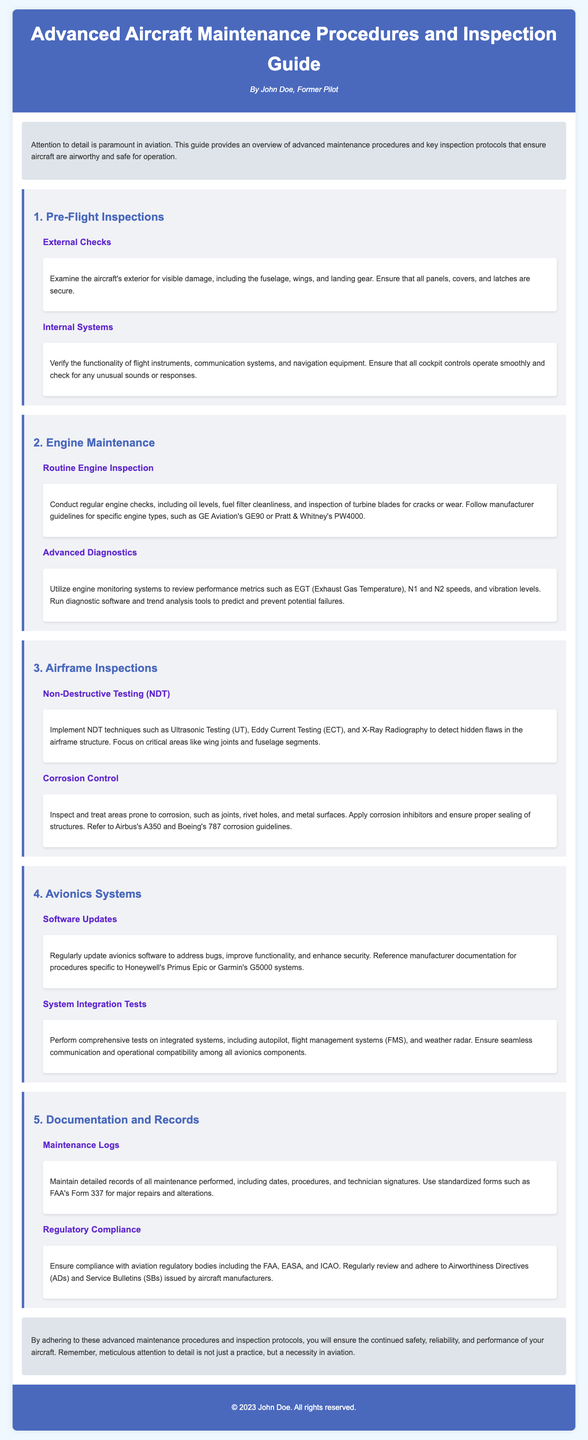What are the key focuses of pre-flight inspections? The pre-flight inspections are focused on external checks and internal systems to ensure aircraft safety.
Answer: External checks, internal systems Which systems require routine engine inspections? Routine engine inspections include checks on oil levels, fuel filter cleanliness, and inspection of turbine blades.
Answer: Oil levels, fuel filter cleanliness, turbine blades What does NDT stand for in airframe inspections? NDT stands for Non-Destructive Testing, which is used to detect hidden flaws in aircraft structures.
Answer: Non-Destructive Testing What type of maintenance logs should be maintained? Maintenance logs should include detailed records of all maintenance performed, such as dates, procedures, and technician signatures.
Answer: Detailed records How often should avionics software be updated? Avionics software should be updated regularly to address bugs, improve functionality, and enhance security.
Answer: Regularly What is the significance of corrosion inhibitors in maintenance? Corrosion inhibitors play a critical role in treating areas prone to corrosion on the aircraft.
Answer: Treating areas prone to corrosion What should be checked in the engine performance metrics? Engine performance metrics include EGT, N1 and N2 speeds, and vibration levels.
Answer: EGT, N1 and N2 speeds, vibration levels Which regulatory bodies must be complied with in aviation? Compliance is required with regulatory bodies such as the FAA, EASA, and ICAO.
Answer: FAA, EASA, ICAO What does AD stand for in the context of regulatory compliance? AD stands for Airworthiness Directives, which are vital for aircraft safety.
Answer: Airworthiness Directives 